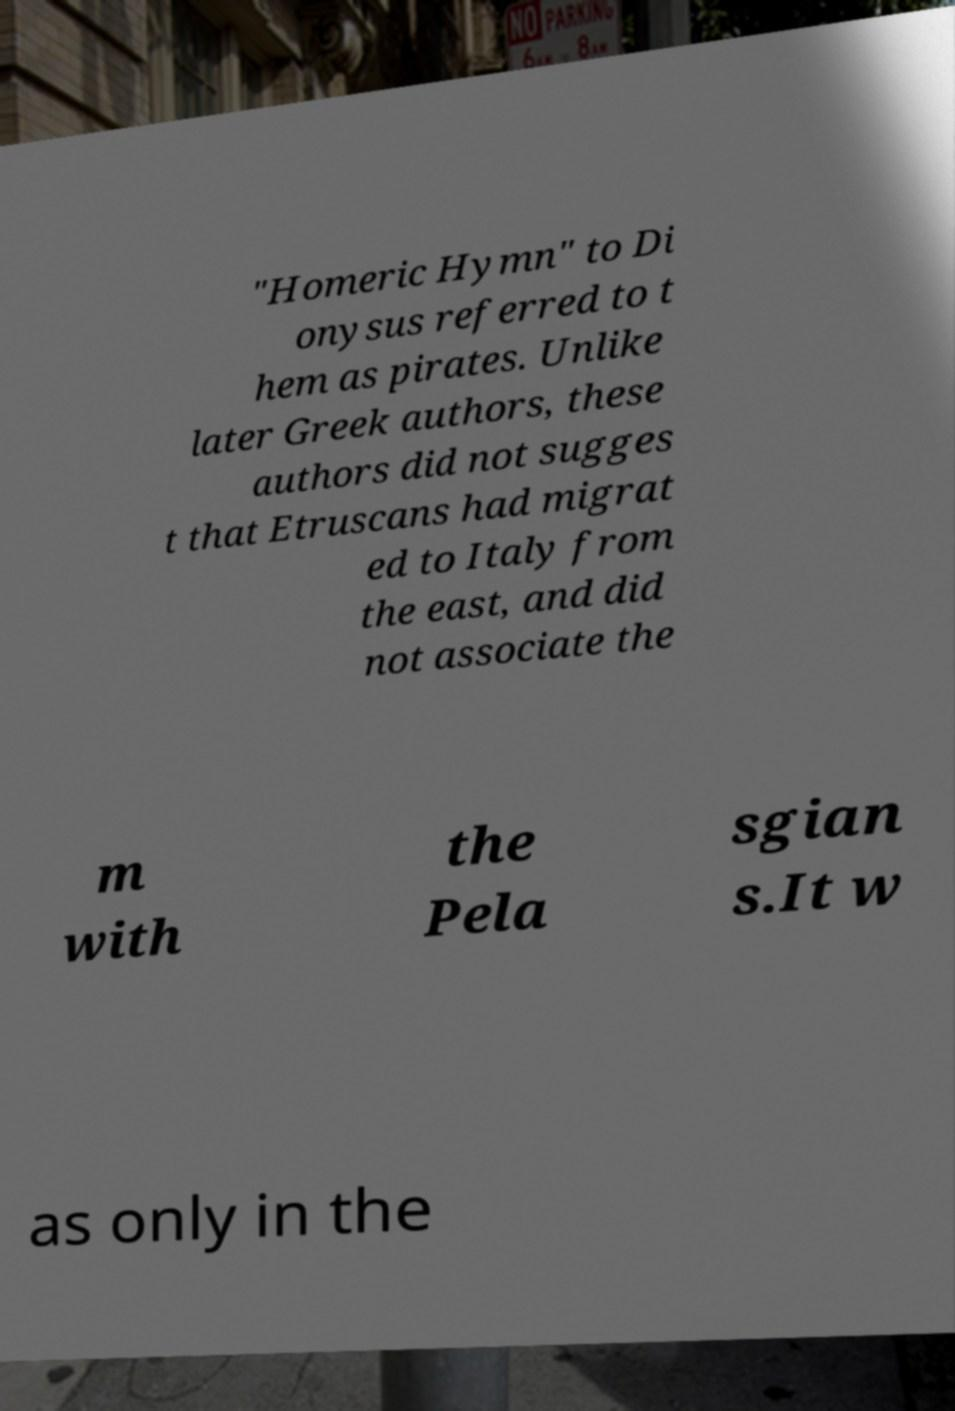Can you accurately transcribe the text from the provided image for me? "Homeric Hymn" to Di onysus referred to t hem as pirates. Unlike later Greek authors, these authors did not sugges t that Etruscans had migrat ed to Italy from the east, and did not associate the m with the Pela sgian s.It w as only in the 